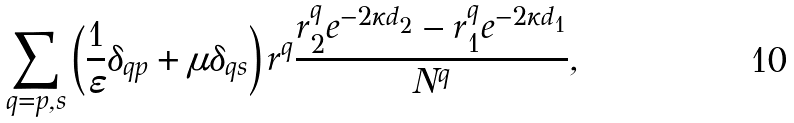Convert formula to latex. <formula><loc_0><loc_0><loc_500><loc_500>\sum _ { q = p , s } \left ( \frac { 1 } { \varepsilon } \delta _ { q p } + \mu \delta _ { q s } \right ) r ^ { q } \frac { r ^ { q } _ { 2 } e ^ { - 2 \kappa d _ { 2 } } - r ^ { q } _ { 1 } e ^ { - 2 \kappa d _ { 1 } } } { N ^ { q } } ,</formula> 